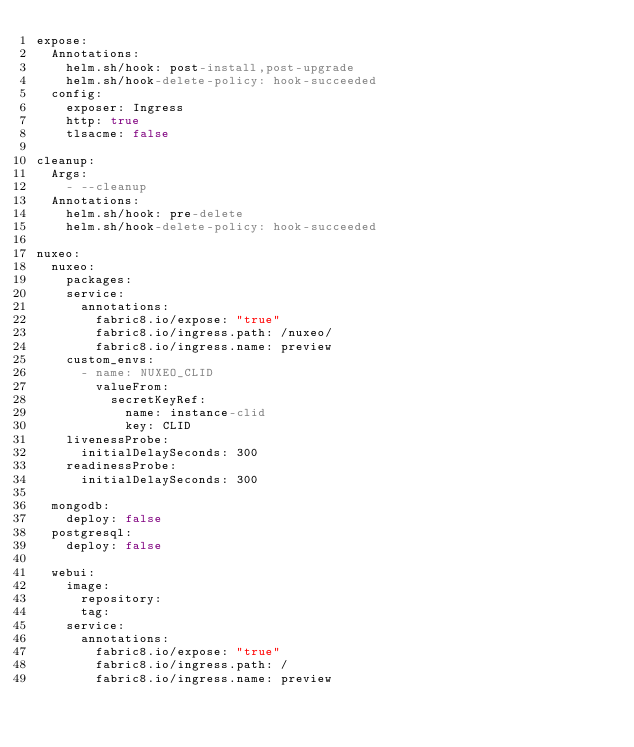Convert code to text. <code><loc_0><loc_0><loc_500><loc_500><_YAML_>expose:
  Annotations:
    helm.sh/hook: post-install,post-upgrade
    helm.sh/hook-delete-policy: hook-succeeded
  config:
    exposer: Ingress
    http: true
    tlsacme: false

cleanup:
  Args:
    - --cleanup
  Annotations:
    helm.sh/hook: pre-delete
    helm.sh/hook-delete-policy: hook-succeeded

nuxeo:
  nuxeo:
    packages:
    service:
      annotations:
        fabric8.io/expose: "true"
        fabric8.io/ingress.path: /nuxeo/
        fabric8.io/ingress.name: preview
    custom_envs:
      - name: NUXEO_CLID
        valueFrom:
          secretKeyRef:
            name: instance-clid
            key: CLID
    livenessProbe:
      initialDelaySeconds: 300
    readinessProbe:
      initialDelaySeconds: 300
      
  mongodb:
    deploy: false
  postgresql:
    deploy: false

  webui:
    image:
      repository:
      tag:
    service:
      annotations:
        fabric8.io/expose: "true"
        fabric8.io/ingress.path: /
        fabric8.io/ingress.name: preview
</code> 